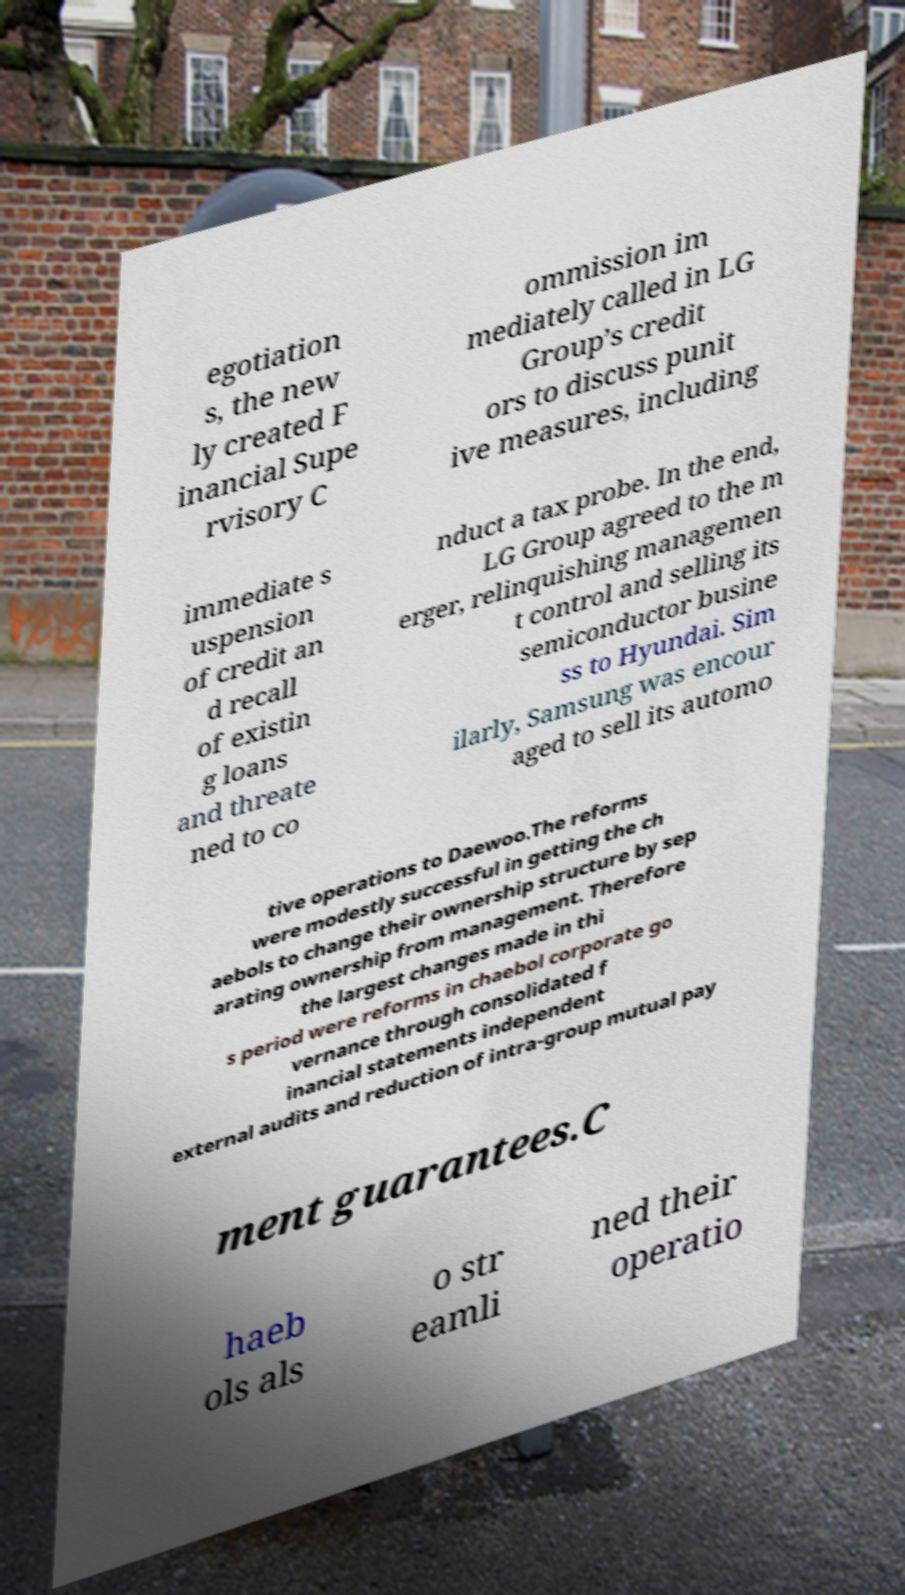What messages or text are displayed in this image? I need them in a readable, typed format. egotiation s, the new ly created F inancial Supe rvisory C ommission im mediately called in LG Group’s credit ors to discuss punit ive measures, including immediate s uspension of credit an d recall of existin g loans and threate ned to co nduct a tax probe. In the end, LG Group agreed to the m erger, relinquishing managemen t control and selling its semiconductor busine ss to Hyundai. Sim ilarly, Samsung was encour aged to sell its automo tive operations to Daewoo.The reforms were modestly successful in getting the ch aebols to change their ownership structure by sep arating ownership from management. Therefore the largest changes made in thi s period were reforms in chaebol corporate go vernance through consolidated f inancial statements independent external audits and reduction of intra-group mutual pay ment guarantees.C haeb ols als o str eamli ned their operatio 